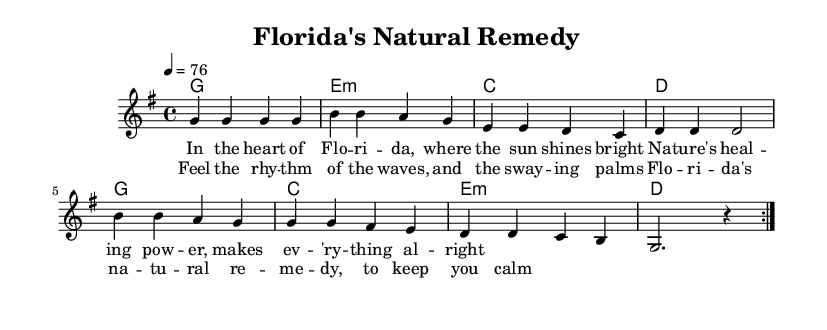What is the key signature of this music? The key signature is G major, which has one sharp (F#). This is identified by looking at the key signature at the beginning of the sheet music, which indicates that G major is the tonality used throughout.
Answer: G major What is the time signature of the piece? The time signature is 4/4, which can be seen at the beginning of the sheet music. It shows that each measure contains four beats, and each beat corresponds to a quarter note.
Answer: 4/4 What is the tempo marking of this music piece? The tempo marking is 76, which represents the metronome marking of beats per minute. This tempo is found in the initial part of the score and indicates how fast the piece should be played.
Answer: 76 What chords are used in the verse? The chords used in the verse are G, Em, C, and D, which can be found in the chord mode section listed under "verse." These chords support the melody in the verse.
Answer: G, Em, C, D How many times is the verse repeated? The verse is repeated twice, as indicated by the notation “\repeat volta 2” before the melody. This means that the section following this command should be played two times consecutively.
Answer: 2 What is the lyrical theme of the chorus? The lyrical theme of the chorus revolves around the healing power of Florida's nature, mentioning the rhythm of the waves and swaying palms. This can be inferred from the lyrics provided for the chorus, which emphasize a sense of calm and natural remedy.
Answer: Healing power of nature What distinguishes this piece as a Reggae song? The piece is characterized as a Reggae song primarily due to its rhythmic feel, which is typically laid-back, and its lyrical focus on nature's healing properties, which is common in Reggae music. This can be deduced from the structure and style indicated in the sheet music.
Answer: Laid-back rhythm 